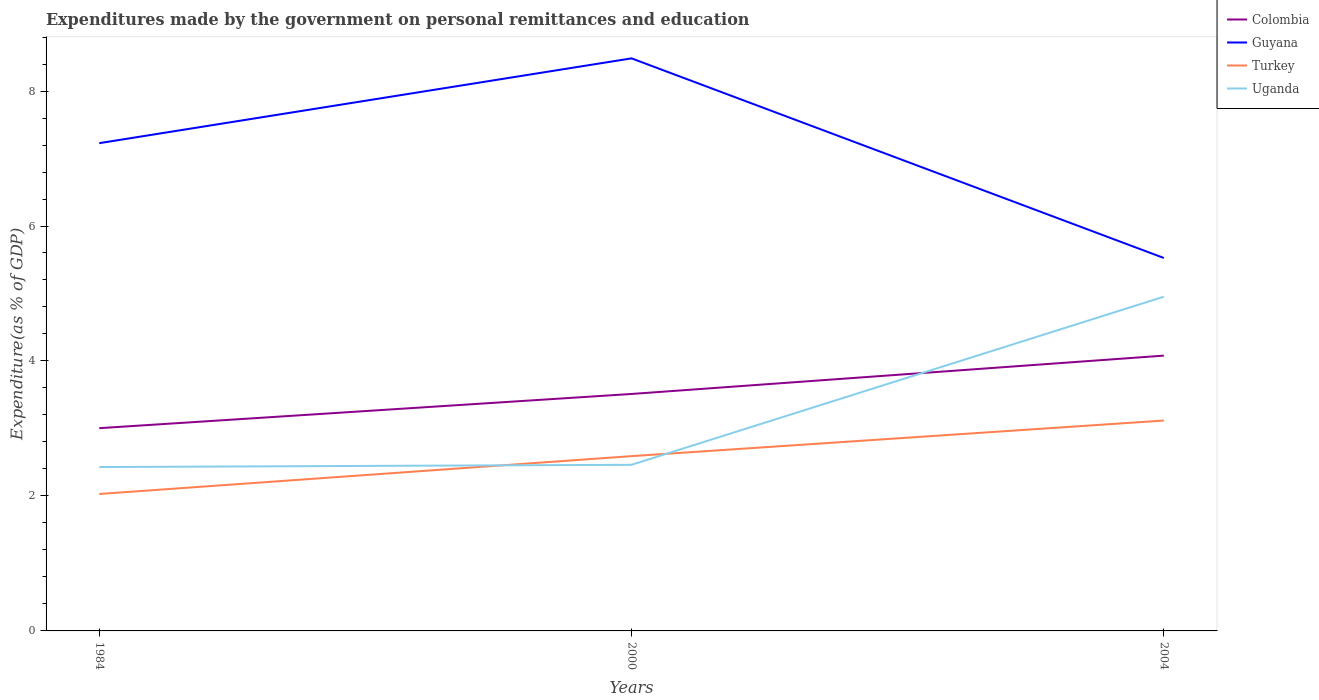How many different coloured lines are there?
Your response must be concise. 4. Does the line corresponding to Colombia intersect with the line corresponding to Turkey?
Offer a terse response. No. Across all years, what is the maximum expenditures made by the government on personal remittances and education in Uganda?
Make the answer very short. 2.43. In which year was the expenditures made by the government on personal remittances and education in Guyana maximum?
Your answer should be compact. 2004. What is the total expenditures made by the government on personal remittances and education in Guyana in the graph?
Offer a terse response. -1.26. What is the difference between the highest and the second highest expenditures made by the government on personal remittances and education in Colombia?
Ensure brevity in your answer.  1.08. How many lines are there?
Provide a short and direct response. 4. What is the difference between two consecutive major ticks on the Y-axis?
Your response must be concise. 2. Are the values on the major ticks of Y-axis written in scientific E-notation?
Your response must be concise. No. Does the graph contain any zero values?
Make the answer very short. No. Where does the legend appear in the graph?
Your answer should be very brief. Top right. How many legend labels are there?
Give a very brief answer. 4. What is the title of the graph?
Your response must be concise. Expenditures made by the government on personal remittances and education. What is the label or title of the X-axis?
Your answer should be compact. Years. What is the label or title of the Y-axis?
Give a very brief answer. Expenditure(as % of GDP). What is the Expenditure(as % of GDP) in Colombia in 1984?
Ensure brevity in your answer.  3. What is the Expenditure(as % of GDP) of Guyana in 1984?
Provide a succinct answer. 7.23. What is the Expenditure(as % of GDP) in Turkey in 1984?
Provide a short and direct response. 2.03. What is the Expenditure(as % of GDP) of Uganda in 1984?
Make the answer very short. 2.43. What is the Expenditure(as % of GDP) of Colombia in 2000?
Your answer should be compact. 3.51. What is the Expenditure(as % of GDP) of Guyana in 2000?
Give a very brief answer. 8.48. What is the Expenditure(as % of GDP) of Turkey in 2000?
Your answer should be compact. 2.59. What is the Expenditure(as % of GDP) of Uganda in 2000?
Your answer should be very brief. 2.46. What is the Expenditure(as % of GDP) in Colombia in 2004?
Ensure brevity in your answer.  4.08. What is the Expenditure(as % of GDP) in Guyana in 2004?
Your answer should be compact. 5.53. What is the Expenditure(as % of GDP) of Turkey in 2004?
Give a very brief answer. 3.12. What is the Expenditure(as % of GDP) of Uganda in 2004?
Your answer should be very brief. 4.95. Across all years, what is the maximum Expenditure(as % of GDP) in Colombia?
Your answer should be very brief. 4.08. Across all years, what is the maximum Expenditure(as % of GDP) of Guyana?
Provide a short and direct response. 8.48. Across all years, what is the maximum Expenditure(as % of GDP) of Turkey?
Give a very brief answer. 3.12. Across all years, what is the maximum Expenditure(as % of GDP) of Uganda?
Your answer should be very brief. 4.95. Across all years, what is the minimum Expenditure(as % of GDP) in Colombia?
Your response must be concise. 3. Across all years, what is the minimum Expenditure(as % of GDP) in Guyana?
Your response must be concise. 5.53. Across all years, what is the minimum Expenditure(as % of GDP) of Turkey?
Your answer should be compact. 2.03. Across all years, what is the minimum Expenditure(as % of GDP) of Uganda?
Your answer should be compact. 2.43. What is the total Expenditure(as % of GDP) in Colombia in the graph?
Provide a succinct answer. 10.59. What is the total Expenditure(as % of GDP) of Guyana in the graph?
Give a very brief answer. 21.24. What is the total Expenditure(as % of GDP) in Turkey in the graph?
Your answer should be compact. 7.74. What is the total Expenditure(as % of GDP) of Uganda in the graph?
Keep it short and to the point. 9.84. What is the difference between the Expenditure(as % of GDP) of Colombia in 1984 and that in 2000?
Provide a short and direct response. -0.51. What is the difference between the Expenditure(as % of GDP) in Guyana in 1984 and that in 2000?
Offer a terse response. -1.26. What is the difference between the Expenditure(as % of GDP) in Turkey in 1984 and that in 2000?
Provide a succinct answer. -0.56. What is the difference between the Expenditure(as % of GDP) in Uganda in 1984 and that in 2000?
Make the answer very short. -0.03. What is the difference between the Expenditure(as % of GDP) in Colombia in 1984 and that in 2004?
Your response must be concise. -1.08. What is the difference between the Expenditure(as % of GDP) in Guyana in 1984 and that in 2004?
Ensure brevity in your answer.  1.7. What is the difference between the Expenditure(as % of GDP) of Turkey in 1984 and that in 2004?
Your answer should be compact. -1.09. What is the difference between the Expenditure(as % of GDP) in Uganda in 1984 and that in 2004?
Your answer should be very brief. -2.52. What is the difference between the Expenditure(as % of GDP) of Colombia in 2000 and that in 2004?
Your answer should be very brief. -0.57. What is the difference between the Expenditure(as % of GDP) of Guyana in 2000 and that in 2004?
Offer a very short reply. 2.96. What is the difference between the Expenditure(as % of GDP) of Turkey in 2000 and that in 2004?
Keep it short and to the point. -0.53. What is the difference between the Expenditure(as % of GDP) of Uganda in 2000 and that in 2004?
Offer a terse response. -2.49. What is the difference between the Expenditure(as % of GDP) of Colombia in 1984 and the Expenditure(as % of GDP) of Guyana in 2000?
Provide a short and direct response. -5.48. What is the difference between the Expenditure(as % of GDP) of Colombia in 1984 and the Expenditure(as % of GDP) of Turkey in 2000?
Provide a succinct answer. 0.41. What is the difference between the Expenditure(as % of GDP) in Colombia in 1984 and the Expenditure(as % of GDP) in Uganda in 2000?
Keep it short and to the point. 0.54. What is the difference between the Expenditure(as % of GDP) of Guyana in 1984 and the Expenditure(as % of GDP) of Turkey in 2000?
Keep it short and to the point. 4.64. What is the difference between the Expenditure(as % of GDP) in Guyana in 1984 and the Expenditure(as % of GDP) in Uganda in 2000?
Your answer should be very brief. 4.77. What is the difference between the Expenditure(as % of GDP) in Turkey in 1984 and the Expenditure(as % of GDP) in Uganda in 2000?
Offer a terse response. -0.43. What is the difference between the Expenditure(as % of GDP) of Colombia in 1984 and the Expenditure(as % of GDP) of Guyana in 2004?
Your answer should be very brief. -2.52. What is the difference between the Expenditure(as % of GDP) of Colombia in 1984 and the Expenditure(as % of GDP) of Turkey in 2004?
Ensure brevity in your answer.  -0.11. What is the difference between the Expenditure(as % of GDP) of Colombia in 1984 and the Expenditure(as % of GDP) of Uganda in 2004?
Provide a short and direct response. -1.95. What is the difference between the Expenditure(as % of GDP) in Guyana in 1984 and the Expenditure(as % of GDP) in Turkey in 2004?
Ensure brevity in your answer.  4.11. What is the difference between the Expenditure(as % of GDP) of Guyana in 1984 and the Expenditure(as % of GDP) of Uganda in 2004?
Your answer should be compact. 2.28. What is the difference between the Expenditure(as % of GDP) in Turkey in 1984 and the Expenditure(as % of GDP) in Uganda in 2004?
Provide a short and direct response. -2.92. What is the difference between the Expenditure(as % of GDP) in Colombia in 2000 and the Expenditure(as % of GDP) in Guyana in 2004?
Your answer should be compact. -2.02. What is the difference between the Expenditure(as % of GDP) of Colombia in 2000 and the Expenditure(as % of GDP) of Turkey in 2004?
Your answer should be very brief. 0.39. What is the difference between the Expenditure(as % of GDP) of Colombia in 2000 and the Expenditure(as % of GDP) of Uganda in 2004?
Your answer should be compact. -1.44. What is the difference between the Expenditure(as % of GDP) of Guyana in 2000 and the Expenditure(as % of GDP) of Turkey in 2004?
Keep it short and to the point. 5.37. What is the difference between the Expenditure(as % of GDP) of Guyana in 2000 and the Expenditure(as % of GDP) of Uganda in 2004?
Your answer should be very brief. 3.53. What is the difference between the Expenditure(as % of GDP) of Turkey in 2000 and the Expenditure(as % of GDP) of Uganda in 2004?
Give a very brief answer. -2.36. What is the average Expenditure(as % of GDP) of Colombia per year?
Ensure brevity in your answer.  3.53. What is the average Expenditure(as % of GDP) in Guyana per year?
Provide a succinct answer. 7.08. What is the average Expenditure(as % of GDP) of Turkey per year?
Provide a succinct answer. 2.58. What is the average Expenditure(as % of GDP) in Uganda per year?
Your response must be concise. 3.28. In the year 1984, what is the difference between the Expenditure(as % of GDP) in Colombia and Expenditure(as % of GDP) in Guyana?
Offer a very short reply. -4.22. In the year 1984, what is the difference between the Expenditure(as % of GDP) of Colombia and Expenditure(as % of GDP) of Turkey?
Your response must be concise. 0.98. In the year 1984, what is the difference between the Expenditure(as % of GDP) of Colombia and Expenditure(as % of GDP) of Uganda?
Make the answer very short. 0.58. In the year 1984, what is the difference between the Expenditure(as % of GDP) in Guyana and Expenditure(as % of GDP) in Turkey?
Give a very brief answer. 5.2. In the year 1984, what is the difference between the Expenditure(as % of GDP) of Guyana and Expenditure(as % of GDP) of Uganda?
Your answer should be very brief. 4.8. In the year 1984, what is the difference between the Expenditure(as % of GDP) in Turkey and Expenditure(as % of GDP) in Uganda?
Give a very brief answer. -0.4. In the year 2000, what is the difference between the Expenditure(as % of GDP) of Colombia and Expenditure(as % of GDP) of Guyana?
Your answer should be compact. -4.97. In the year 2000, what is the difference between the Expenditure(as % of GDP) in Colombia and Expenditure(as % of GDP) in Turkey?
Make the answer very short. 0.92. In the year 2000, what is the difference between the Expenditure(as % of GDP) in Colombia and Expenditure(as % of GDP) in Uganda?
Keep it short and to the point. 1.05. In the year 2000, what is the difference between the Expenditure(as % of GDP) in Guyana and Expenditure(as % of GDP) in Turkey?
Your answer should be very brief. 5.89. In the year 2000, what is the difference between the Expenditure(as % of GDP) of Guyana and Expenditure(as % of GDP) of Uganda?
Give a very brief answer. 6.02. In the year 2000, what is the difference between the Expenditure(as % of GDP) in Turkey and Expenditure(as % of GDP) in Uganda?
Offer a terse response. 0.13. In the year 2004, what is the difference between the Expenditure(as % of GDP) in Colombia and Expenditure(as % of GDP) in Guyana?
Your answer should be compact. -1.45. In the year 2004, what is the difference between the Expenditure(as % of GDP) of Colombia and Expenditure(as % of GDP) of Uganda?
Keep it short and to the point. -0.87. In the year 2004, what is the difference between the Expenditure(as % of GDP) in Guyana and Expenditure(as % of GDP) in Turkey?
Offer a very short reply. 2.41. In the year 2004, what is the difference between the Expenditure(as % of GDP) in Guyana and Expenditure(as % of GDP) in Uganda?
Give a very brief answer. 0.57. In the year 2004, what is the difference between the Expenditure(as % of GDP) in Turkey and Expenditure(as % of GDP) in Uganda?
Ensure brevity in your answer.  -1.83. What is the ratio of the Expenditure(as % of GDP) in Colombia in 1984 to that in 2000?
Give a very brief answer. 0.86. What is the ratio of the Expenditure(as % of GDP) of Guyana in 1984 to that in 2000?
Your response must be concise. 0.85. What is the ratio of the Expenditure(as % of GDP) in Turkey in 1984 to that in 2000?
Make the answer very short. 0.78. What is the ratio of the Expenditure(as % of GDP) in Uganda in 1984 to that in 2000?
Ensure brevity in your answer.  0.99. What is the ratio of the Expenditure(as % of GDP) of Colombia in 1984 to that in 2004?
Provide a succinct answer. 0.74. What is the ratio of the Expenditure(as % of GDP) of Guyana in 1984 to that in 2004?
Make the answer very short. 1.31. What is the ratio of the Expenditure(as % of GDP) of Turkey in 1984 to that in 2004?
Your response must be concise. 0.65. What is the ratio of the Expenditure(as % of GDP) of Uganda in 1984 to that in 2004?
Your answer should be very brief. 0.49. What is the ratio of the Expenditure(as % of GDP) in Colombia in 2000 to that in 2004?
Offer a terse response. 0.86. What is the ratio of the Expenditure(as % of GDP) of Guyana in 2000 to that in 2004?
Offer a very short reply. 1.54. What is the ratio of the Expenditure(as % of GDP) of Turkey in 2000 to that in 2004?
Ensure brevity in your answer.  0.83. What is the ratio of the Expenditure(as % of GDP) in Uganda in 2000 to that in 2004?
Provide a short and direct response. 0.5. What is the difference between the highest and the second highest Expenditure(as % of GDP) in Colombia?
Make the answer very short. 0.57. What is the difference between the highest and the second highest Expenditure(as % of GDP) in Guyana?
Give a very brief answer. 1.26. What is the difference between the highest and the second highest Expenditure(as % of GDP) in Turkey?
Provide a short and direct response. 0.53. What is the difference between the highest and the second highest Expenditure(as % of GDP) in Uganda?
Offer a terse response. 2.49. What is the difference between the highest and the lowest Expenditure(as % of GDP) of Colombia?
Keep it short and to the point. 1.08. What is the difference between the highest and the lowest Expenditure(as % of GDP) of Guyana?
Make the answer very short. 2.96. What is the difference between the highest and the lowest Expenditure(as % of GDP) in Turkey?
Offer a very short reply. 1.09. What is the difference between the highest and the lowest Expenditure(as % of GDP) of Uganda?
Your answer should be compact. 2.52. 